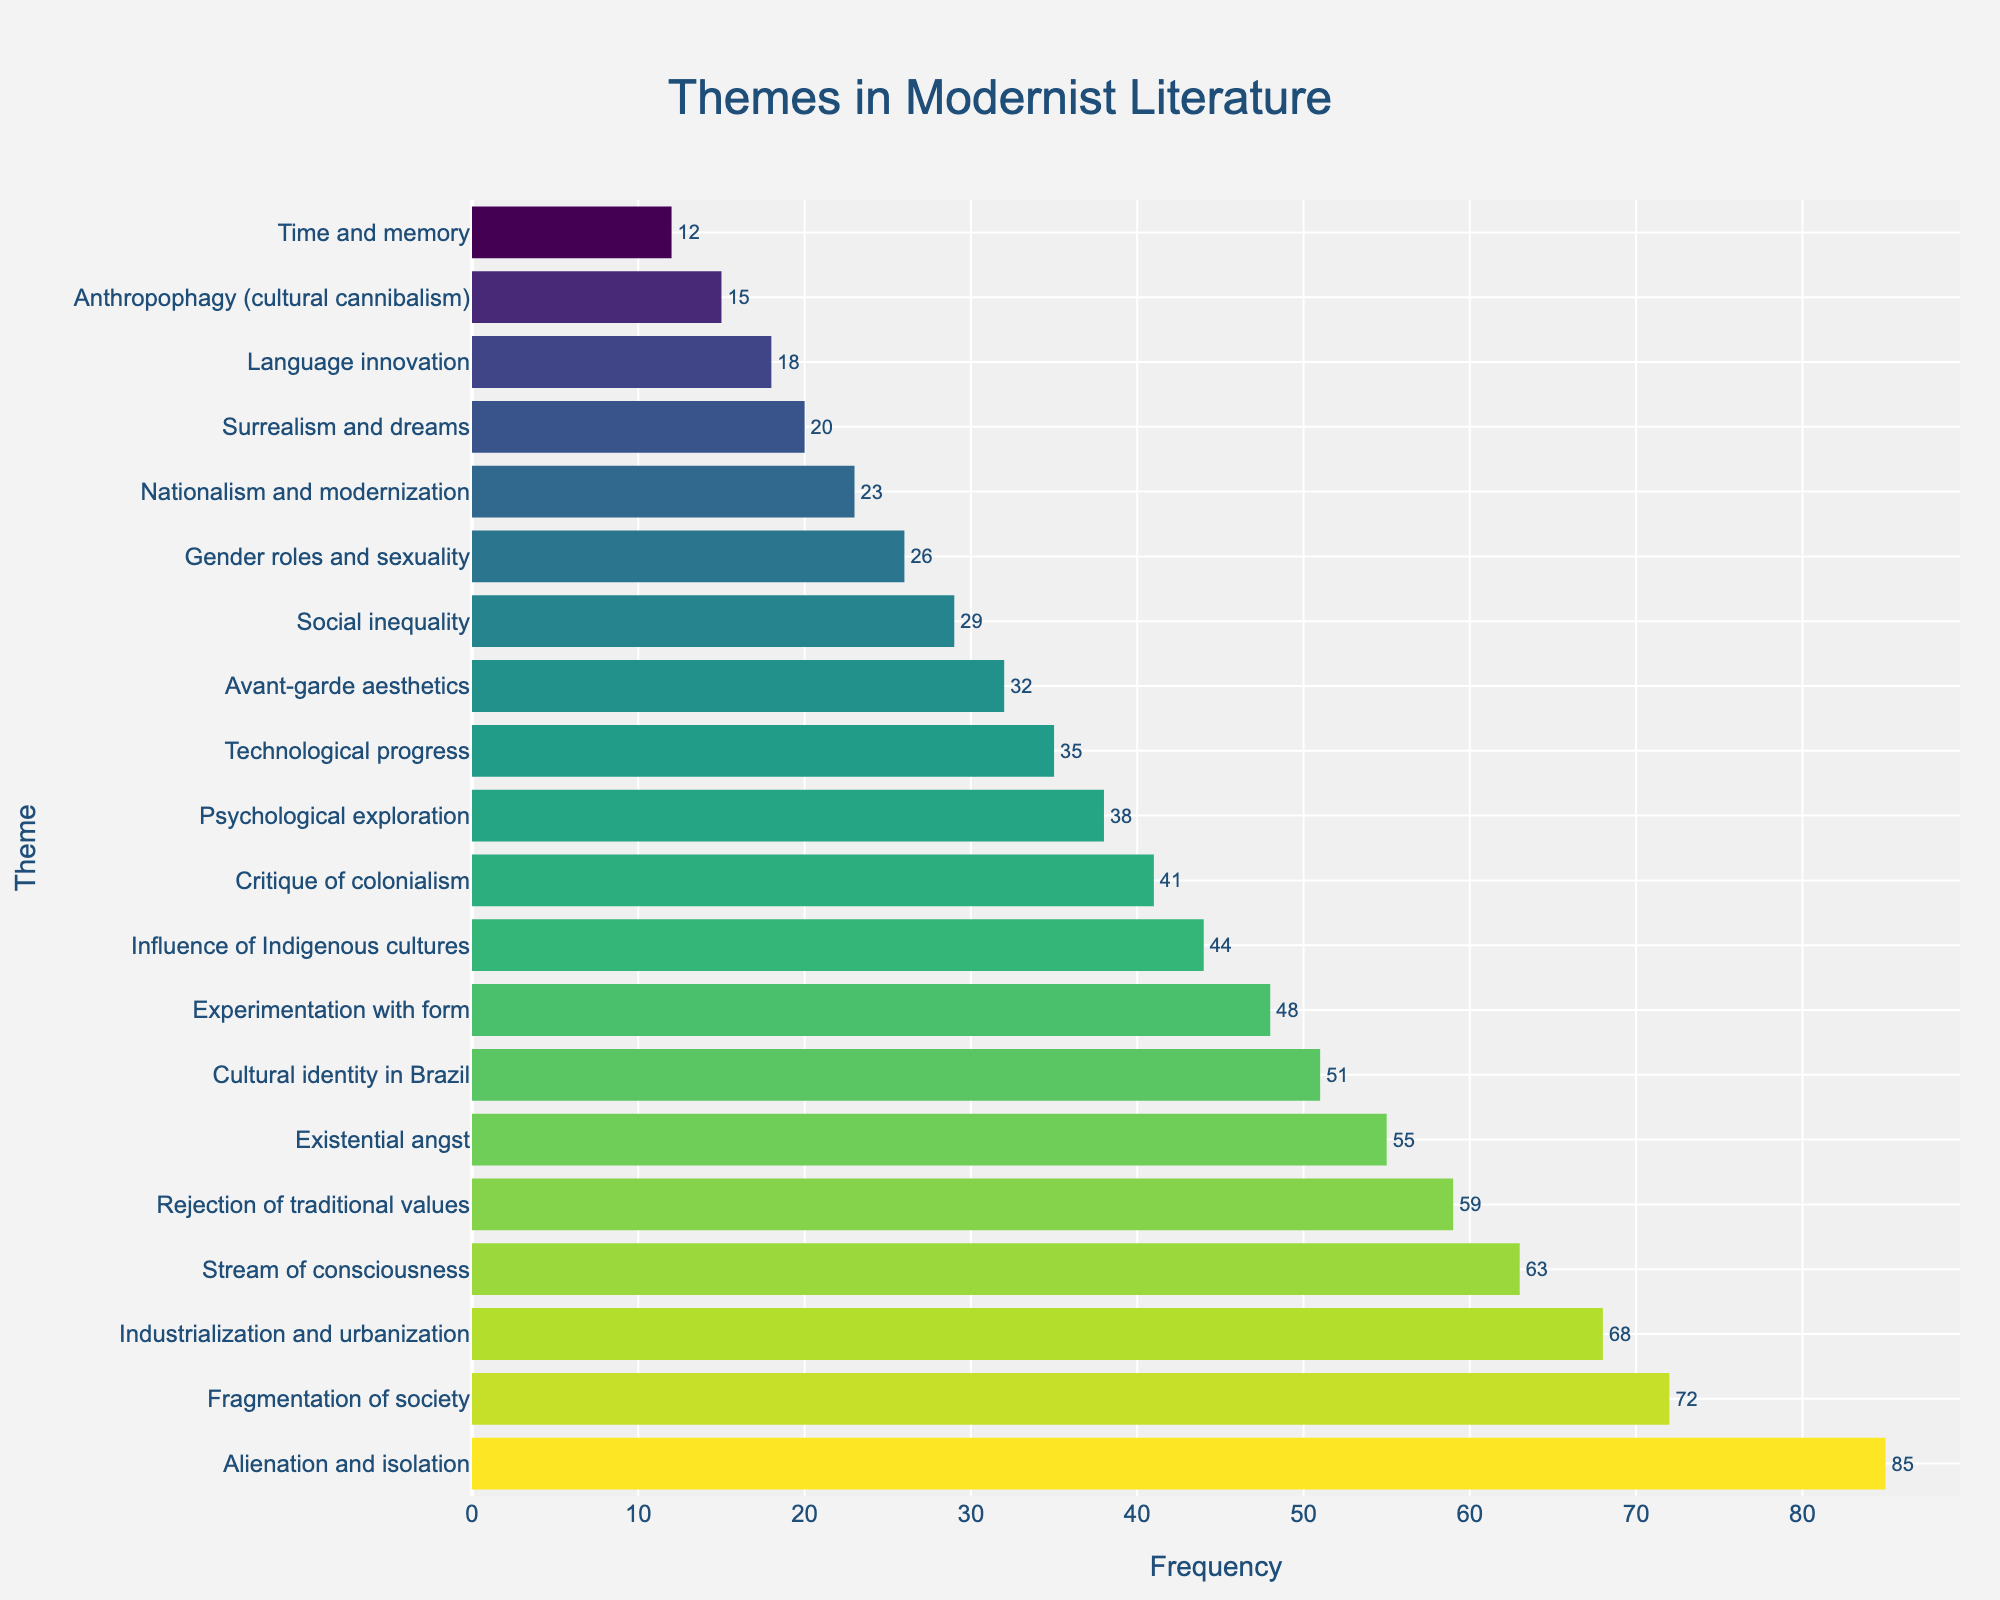Which theme is explored most frequently in Modernist literature? The bar for "Alienation and isolation" is the tallest, indicating it is the most frequently explored theme.
Answer: Alienation and isolation Which theme has a higher frequency: "Cultural identity in Brazil" or "Psychological exploration"? By comparing the length of the bars, "Cultural identity in Brazil" has a longer bar than "Psychological exploration."
Answer: Cultural identity in Brazil What is the total frequency of the top three themes? The frequencies of the top three themes are "Alienation and isolation" (85), "Fragmentation of society" (72), and "Industrialization and urbanization" (68). Their total is 85 + 72 + 68 = 225.
Answer: 225 Which theme has the lowest frequency and what is its frequency? The shortest bar in the chart corresponds to "Time and memory" with a frequency of 12.
Answer: Time and memory, 12 How many themes have a frequency greater than 50? By visually inspecting the bars and counting the ones exceeding the 50 mark, we find themes like "Alienation and isolation," "Fragmentation of society," "Industrialization and urbanization," "Stream of consciousness," "Rejection of traditional values," "Existential angst," and "Cultural identity in Brazil." There are 7 such themes.
Answer: 7 Are there more themes related to identity (Cultural identity in Brazil, Influence of Indigenous cultures) or technology (Technological progress)? "Cultural identity in Brazil" and "Influence of Indigenous cultures" sum to 51 + 44 = 95, while "Technological progress" alone has a frequency of 35. Thus, identity themes are more frequent.
Answer: Identity themes Which theme has a frequency closest to 30 but not below? The theme "Social inequality" has a frequency of 29, which is closest to 30 but is slightly lower. The next closest theme above 30 is "Technological progress" with a frequency of 35.
Answer: Technological progress What is the combined frequency of themes related to experimentation (Experimentation with form, Avant-garde aesthetics)? The frequencies of "Experimentation with form" and "Avant-garde aesthetics" are 48 and 32 respectively. Their combined frequency is 48 + 32 = 80.
Answer: 80 Which theme is more frequent: "Nationalism and modernization" or "Surrealism and dreams"? By comparing the lengths of the bars, "Nationalism and modernization" has a frequency of 23, while "Surrealism and dreams" has a frequency of 20.
Answer: Nationalism and modernization 